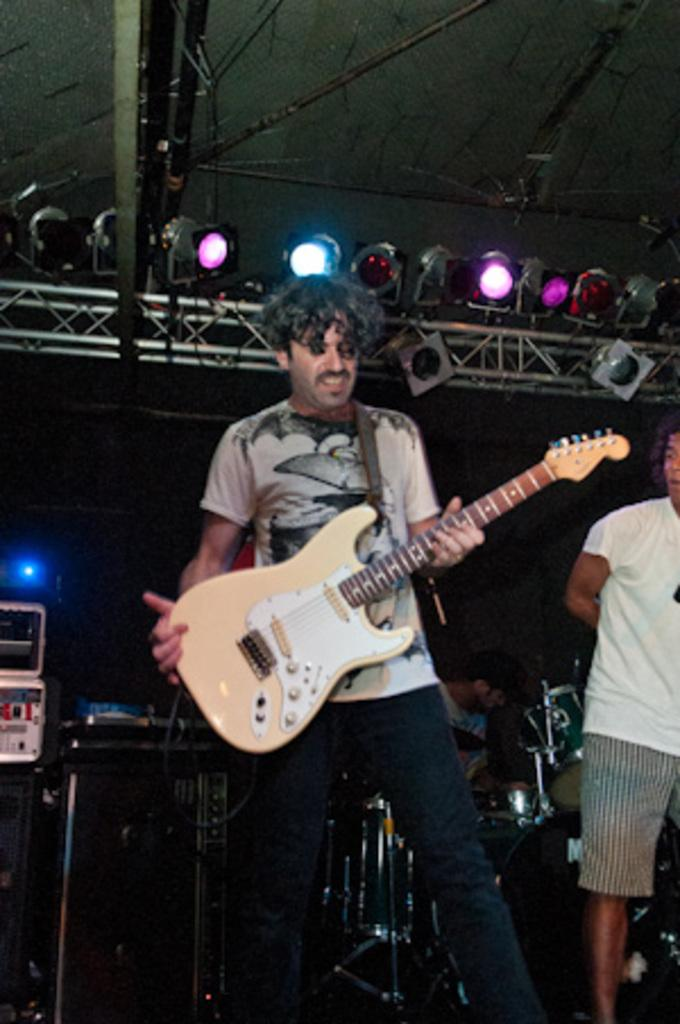What is the man holding in the image? The man is holding a guitar in the image. Who is standing beside the man with a guitar? There is another person standing beside the man with a guitar. What is the third person doing in the image? The third person is sitting and playing a musical instrument. What can be seen at the top of the image? There are focusing lights visible at the top of the image. What type of lunchroom can be seen in the background of the image? There is no lunchroom present in the image. Can you hear the whistle of the person playing the musical instrument in the image? The image is a still picture, so it is not possible to hear any sounds, including a whistle. 